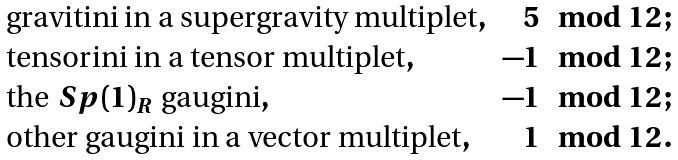Convert formula to latex. <formula><loc_0><loc_0><loc_500><loc_500>\begin{array} { l r c } \text {gravitini in a supergravity multiplet} , & 5 \mod 1 2 \, ; \\ \text {tensorini in a tensor multiplet} , & - 1 \mod 1 2 \, ; \\ \text {the $Sp(1)_{R}$ gaugini} , & - 1 \mod 1 2 \, ; \\ \text {other gaugini in a vector multiplet} , & 1 \mod 1 2 \, . \end{array}</formula> 